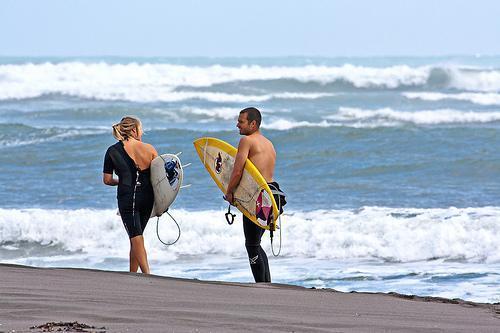How many surfboards?
Give a very brief answer. 2. 